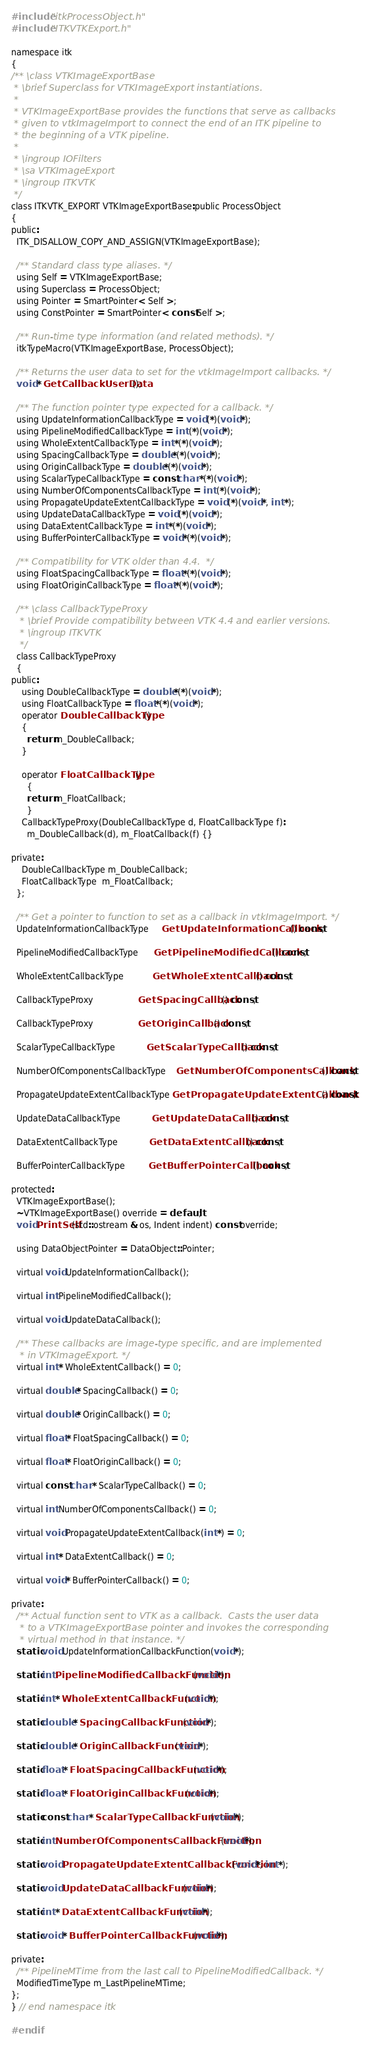Convert code to text. <code><loc_0><loc_0><loc_500><loc_500><_C_>
#include "itkProcessObject.h"
#include "ITKVTKExport.h"

namespace itk
{
/** \class VTKImageExportBase
 * \brief Superclass for VTKImageExport instantiations.
 *
 * VTKImageExportBase provides the functions that serve as callbacks
 * given to vtkImageImport to connect the end of an ITK pipeline to
 * the beginning of a VTK pipeline.
 *
 * \ingroup IOFilters
 * \sa VTKImageExport
 * \ingroup ITKVTK
 */
class ITKVTK_EXPORT VTKImageExportBase:public ProcessObject
{
public:
  ITK_DISALLOW_COPY_AND_ASSIGN(VTKImageExportBase);

  /** Standard class type aliases. */
  using Self = VTKImageExportBase;
  using Superclass = ProcessObject;
  using Pointer = SmartPointer< Self >;
  using ConstPointer = SmartPointer< const Self >;

  /** Run-time type information (and related methods). */
  itkTypeMacro(VTKImageExportBase, ProcessObject);

  /** Returns the user data to set for the vtkImageImport callbacks. */
  void * GetCallbackUserData();

  /** The function pointer type expected for a callback. */
  using UpdateInformationCallbackType = void (*)(void *);
  using PipelineModifiedCallbackType = int (*)(void *);
  using WholeExtentCallbackType = int *(*)(void *);
  using SpacingCallbackType = double *(*)(void *);
  using OriginCallbackType = double *(*)(void *);
  using ScalarTypeCallbackType = const char *(*)(void *);
  using NumberOfComponentsCallbackType = int (*)(void *);
  using PropagateUpdateExtentCallbackType = void (*)(void *, int *);
  using UpdateDataCallbackType = void (*)(void *);
  using DataExtentCallbackType = int *(*)(void *);
  using BufferPointerCallbackType = void *(*)(void *);

  /** Compatibility for VTK older than 4.4.  */
  using FloatSpacingCallbackType = float *(*)(void *);
  using FloatOriginCallbackType = float *(*)(void *);

  /** \class CallbackTypeProxy
   * \brief Provide compatibility between VTK 4.4 and earlier versions.
   * \ingroup ITKVTK
   */
  class CallbackTypeProxy
  {
public:
    using DoubleCallbackType = double *(*)(void *);
    using FloatCallbackType = float *(*)(void *);
    operator DoubleCallbackType()
    {
      return m_DoubleCallback;
    }

    operator FloatCallbackType()
      {
      return m_FloatCallback;
      }
    CallbackTypeProxy(DoubleCallbackType d, FloatCallbackType f):
      m_DoubleCallback(d), m_FloatCallback(f) {}

private:
    DoubleCallbackType m_DoubleCallback;
    FloatCallbackType  m_FloatCallback;
  };

  /** Get a pointer to function to set as a callback in vtkImageImport. */
  UpdateInformationCallbackType     GetUpdateInformationCallback() const;

  PipelineModifiedCallbackType      GetPipelineModifiedCallback() const;

  WholeExtentCallbackType           GetWholeExtentCallback() const;

  CallbackTypeProxy                 GetSpacingCallback() const;

  CallbackTypeProxy                 GetOriginCallback() const;

  ScalarTypeCallbackType            GetScalarTypeCallback() const;

  NumberOfComponentsCallbackType    GetNumberOfComponentsCallback() const;

  PropagateUpdateExtentCallbackType GetPropagateUpdateExtentCallback() const;

  UpdateDataCallbackType            GetUpdateDataCallback() const;

  DataExtentCallbackType            GetDataExtentCallback() const;

  BufferPointerCallbackType         GetBufferPointerCallback() const;

protected:
  VTKImageExportBase();
  ~VTKImageExportBase() override = default;
  void PrintSelf(std::ostream & os, Indent indent) const override;

  using DataObjectPointer = DataObject::Pointer;

  virtual void UpdateInformationCallback();

  virtual int PipelineModifiedCallback();

  virtual void UpdateDataCallback();

  /** These callbacks are image-type specific, and are implemented
   * in VTKImageExport. */
  virtual int * WholeExtentCallback() = 0;

  virtual double * SpacingCallback() = 0;

  virtual double * OriginCallback() = 0;

  virtual float * FloatSpacingCallback() = 0;

  virtual float * FloatOriginCallback() = 0;

  virtual const char * ScalarTypeCallback() = 0;

  virtual int NumberOfComponentsCallback() = 0;

  virtual void PropagateUpdateExtentCallback(int *) = 0;

  virtual int * DataExtentCallback() = 0;

  virtual void * BufferPointerCallback() = 0;

private:
  /** Actual function sent to VTK as a callback.  Casts the user data
   * to a VTKImageExportBase pointer and invokes the corresponding
   * virtual method in that instance. */
  static void UpdateInformationCallbackFunction(void *);

  static int PipelineModifiedCallbackFunction(void *);

  static int * WholeExtentCallbackFunction(void *);

  static double * SpacingCallbackFunction(void *);

  static double * OriginCallbackFunction(void *);

  static float * FloatSpacingCallbackFunction(void *);

  static float * FloatOriginCallbackFunction(void *);

  static const char * ScalarTypeCallbackFunction(void *);

  static int NumberOfComponentsCallbackFunction(void *);

  static void PropagateUpdateExtentCallbackFunction(void *, int *);

  static void UpdateDataCallbackFunction(void *);

  static int * DataExtentCallbackFunction(void *);

  static void * BufferPointerCallbackFunction(void *);

private:
  /** PipelineMTime from the last call to PipelineModifiedCallback. */
  ModifiedTimeType m_LastPipelineMTime;
};
} // end namespace itk

#endif
</code> 